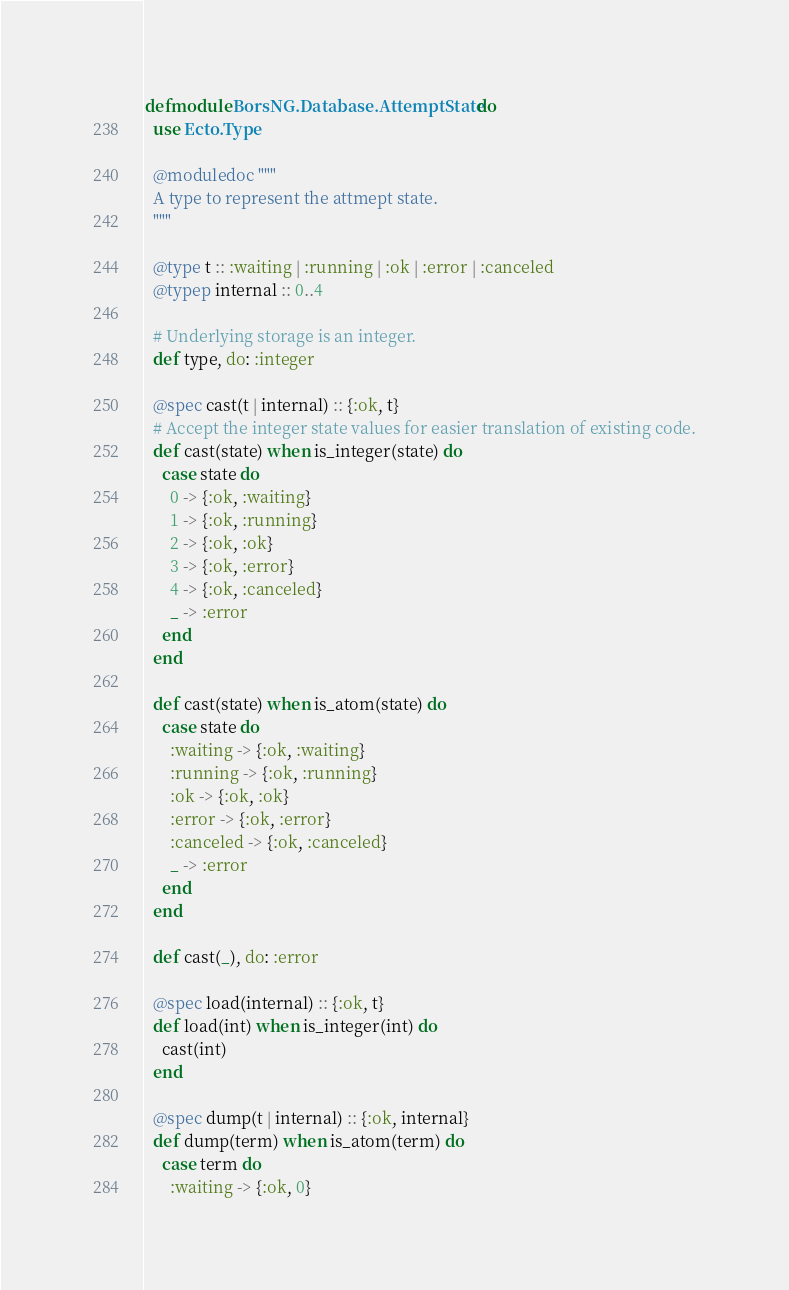Convert code to text. <code><loc_0><loc_0><loc_500><loc_500><_Elixir_>defmodule BorsNG.Database.AttemptState do
  use Ecto.Type

  @moduledoc """
  A type to represent the attmept state.
  """

  @type t :: :waiting | :running | :ok | :error | :canceled
  @typep internal :: 0..4

  # Underlying storage is an integer.
  def type, do: :integer

  @spec cast(t | internal) :: {:ok, t}
  # Accept the integer state values for easier translation of existing code.
  def cast(state) when is_integer(state) do
    case state do
      0 -> {:ok, :waiting}
      1 -> {:ok, :running}
      2 -> {:ok, :ok}
      3 -> {:ok, :error}
      4 -> {:ok, :canceled}
      _ -> :error
    end
  end

  def cast(state) when is_atom(state) do
    case state do
      :waiting -> {:ok, :waiting}
      :running -> {:ok, :running}
      :ok -> {:ok, :ok}
      :error -> {:ok, :error}
      :canceled -> {:ok, :canceled}
      _ -> :error
    end
  end

  def cast(_), do: :error

  @spec load(internal) :: {:ok, t}
  def load(int) when is_integer(int) do
    cast(int)
  end

  @spec dump(t | internal) :: {:ok, internal}
  def dump(term) when is_atom(term) do
    case term do
      :waiting -> {:ok, 0}</code> 